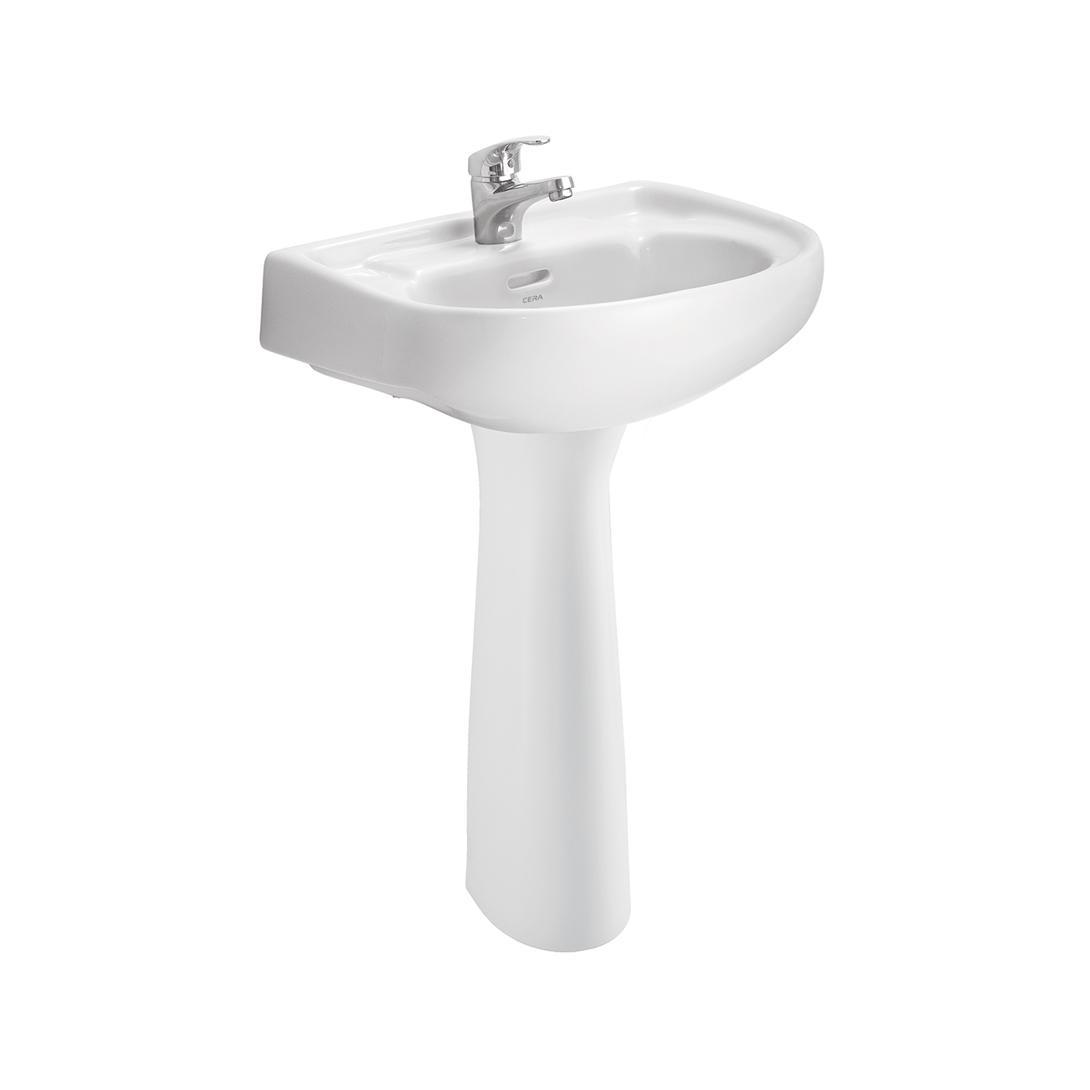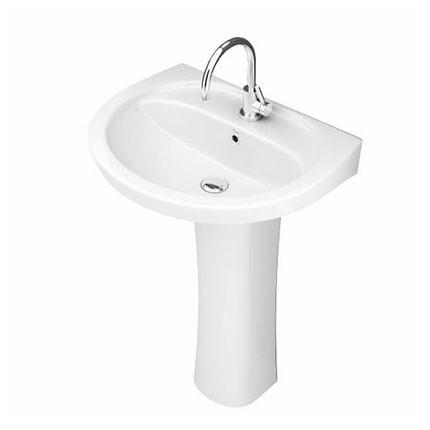The first image is the image on the left, the second image is the image on the right. Examine the images to the left and right. Is the description "One image shows a rectangular, nonpedestal sink with an integrated flat counter." accurate? Answer yes or no. No. 